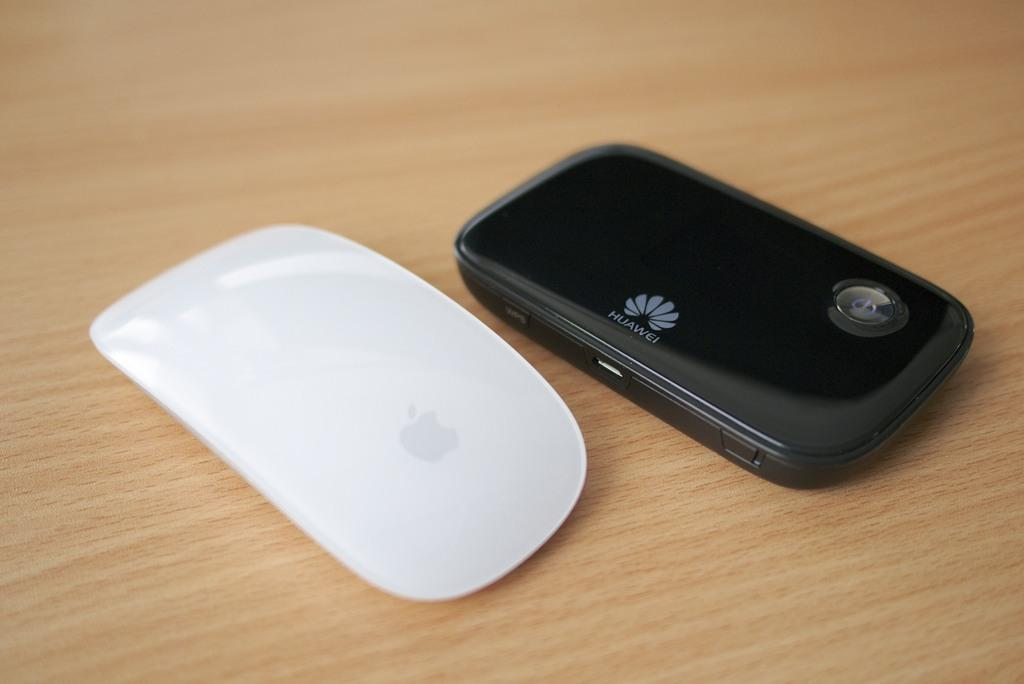<image>
Summarize the visual content of the image. An Apple product and a Huawei phone are sitting next to each other on a table. 